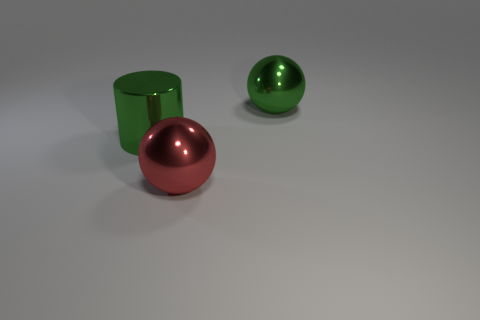Can you describe the play of light on the surfaces of the objects? Certainly! The objects in the image display specular highlights, indicating they have reflective surfaces. The light creates bright spots on the tops of the objects where it is most directly hitting them, and the reflections are crisp, suggesting the surfaces are smooth and polished. 